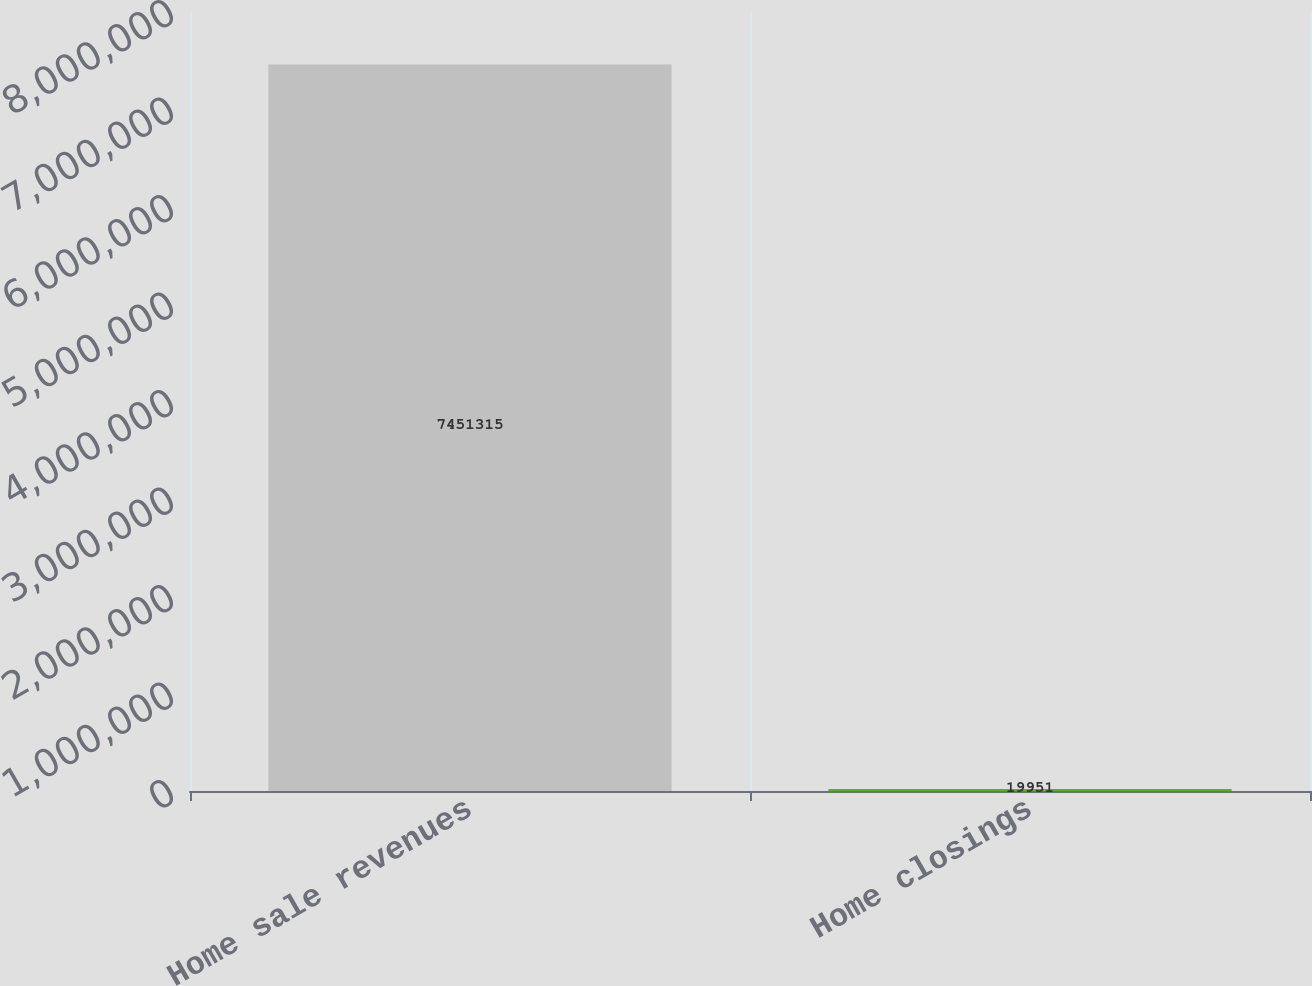Convert chart. <chart><loc_0><loc_0><loc_500><loc_500><bar_chart><fcel>Home sale revenues<fcel>Home closings<nl><fcel>7.45132e+06<fcel>19951<nl></chart> 